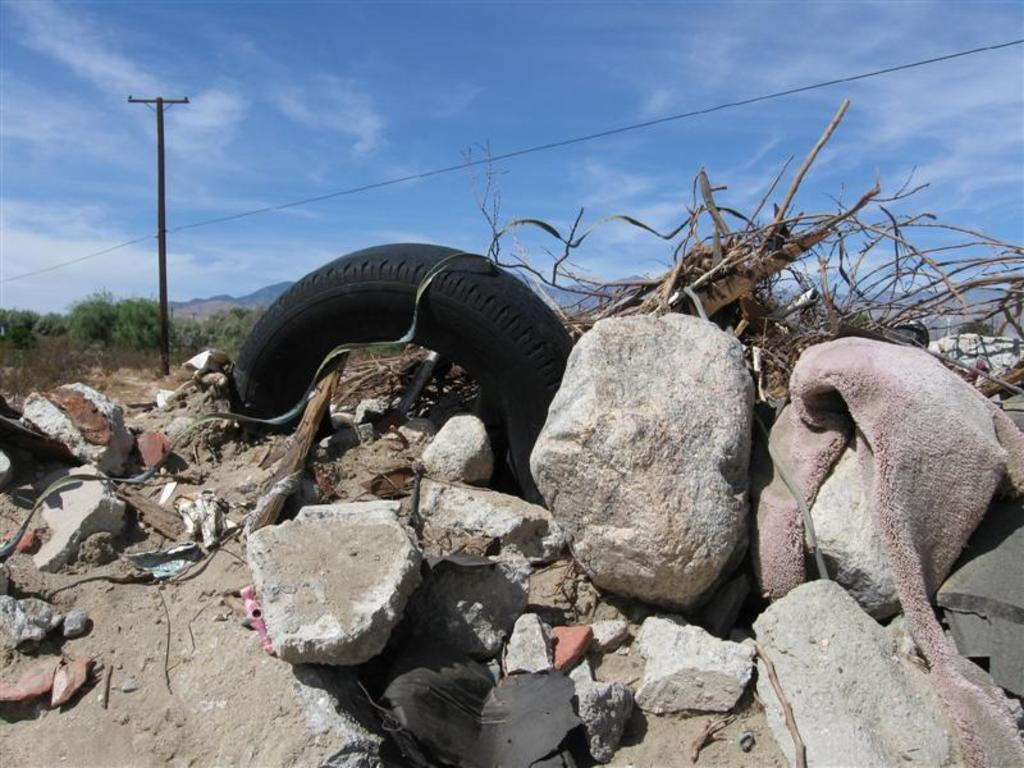What object is the main focus of the image? There is a tire in the image. What other objects can be seen in the image? There are rocks and twigs visible in the image. What is visible in the background of the image? There are trees in the background of the image. What man-made structure is present in the image? There is an electric pole in the image. What is the condition of the sky in the image? The sky is clear in the image. What type of drink is being served in the image? There is no drink present in the image; it features a tire, rocks, twigs, trees, an electric pole, and a clear sky. 